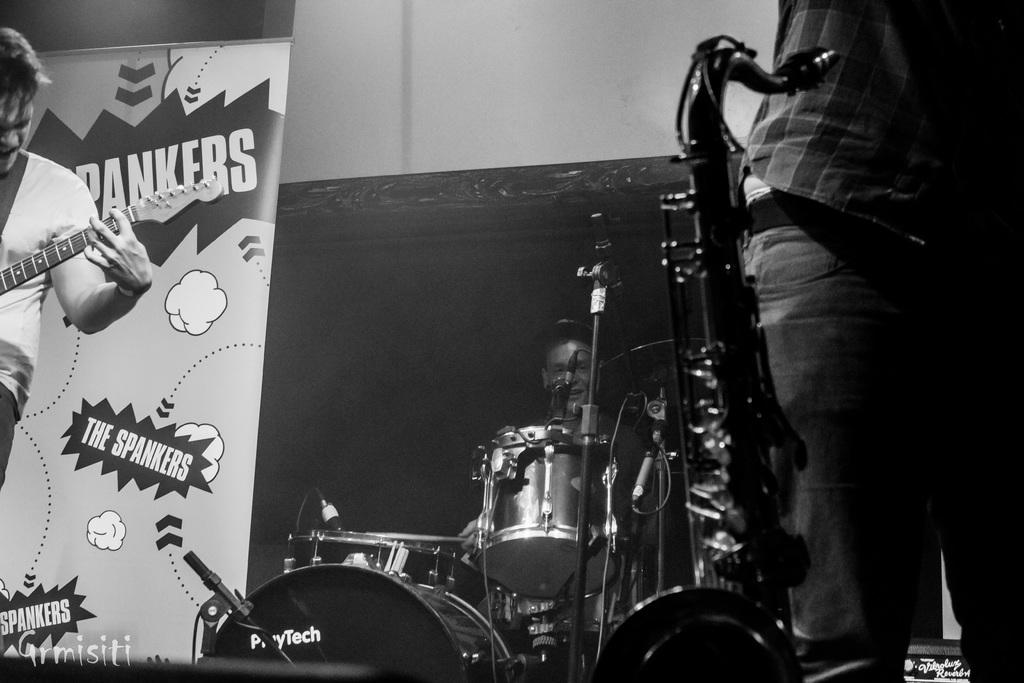How many people are in the image? There are people in the image, but the exact number is not specified. What is the man doing in the image? The man is playing a guitar in the image. What other musical instruments are present? There are musical instruments in the image, but the specific types are not mentioned. What can be seen hanging in the image? There is a banner in the image. What is the color of the background in the image? The background of the image is dark. What type of government debt is being discussed in the image? There is no mention of government debt in the image; it features people, a man playing a guitar, musical instruments, a banner, and a dark background. 